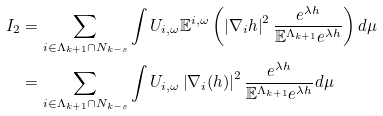<formula> <loc_0><loc_0><loc_500><loc_500>I _ { 2 } & = \sum _ { i \in \Lambda _ { k + 1 } \cap N _ { k - s } } \int U _ { i , \omega } \mathbb { E } ^ { i , \omega } \left ( \left | \nabla _ { i } h \right | ^ { 2 } \frac { e ^ { \lambda h } } { \mathbb { E } ^ { \Lambda _ { k + 1 } } e ^ { \lambda h } } \right ) d \mu \\ & = \sum _ { i \in \Lambda _ { k + 1 } \cap N _ { k - s } } \int U _ { i , \omega } \left | \nabla _ { i } ( h ) \right | ^ { 2 } \frac { e ^ { \lambda h } } { \mathbb { E } ^ { \Lambda _ { k + 1 } } e ^ { \lambda h } } d \mu</formula> 